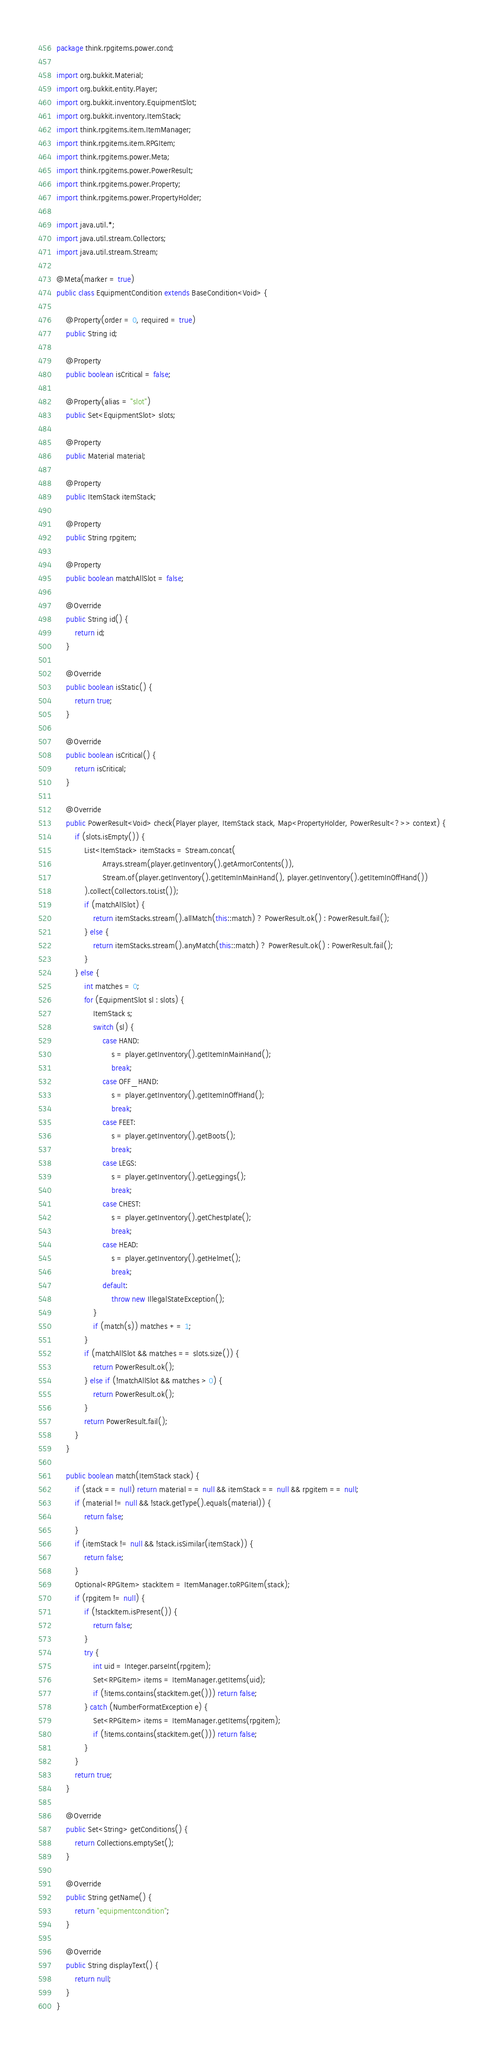Convert code to text. <code><loc_0><loc_0><loc_500><loc_500><_Java_>package think.rpgitems.power.cond;

import org.bukkit.Material;
import org.bukkit.entity.Player;
import org.bukkit.inventory.EquipmentSlot;
import org.bukkit.inventory.ItemStack;
import think.rpgitems.item.ItemManager;
import think.rpgitems.item.RPGItem;
import think.rpgitems.power.Meta;
import think.rpgitems.power.PowerResult;
import think.rpgitems.power.Property;
import think.rpgitems.power.PropertyHolder;

import java.util.*;
import java.util.stream.Collectors;
import java.util.stream.Stream;

@Meta(marker = true)
public class EquipmentCondition extends BaseCondition<Void> {

    @Property(order = 0, required = true)
    public String id;

    @Property
    public boolean isCritical = false;

    @Property(alias = "slot")
    public Set<EquipmentSlot> slots;

    @Property
    public Material material;

    @Property
    public ItemStack itemStack;

    @Property
    public String rpgitem;

    @Property
    public boolean matchAllSlot = false;

    @Override
    public String id() {
        return id;
    }

    @Override
    public boolean isStatic() {
        return true;
    }

    @Override
    public boolean isCritical() {
        return isCritical;
    }

    @Override
    public PowerResult<Void> check(Player player, ItemStack stack, Map<PropertyHolder, PowerResult<?>> context) {
        if (slots.isEmpty()) {
            List<ItemStack> itemStacks = Stream.concat(
                    Arrays.stream(player.getInventory().getArmorContents()),
                    Stream.of(player.getInventory().getItemInMainHand(), player.getInventory().getItemInOffHand())
            ).collect(Collectors.toList());
            if (matchAllSlot) {
                return itemStacks.stream().allMatch(this::match) ? PowerResult.ok() : PowerResult.fail();
            } else {
                return itemStacks.stream().anyMatch(this::match) ? PowerResult.ok() : PowerResult.fail();
            }
        } else {
            int matches = 0;
            for (EquipmentSlot sl : slots) {
                ItemStack s;
                switch (sl) {
                    case HAND:
                        s = player.getInventory().getItemInMainHand();
                        break;
                    case OFF_HAND:
                        s = player.getInventory().getItemInOffHand();
                        break;
                    case FEET:
                        s = player.getInventory().getBoots();
                        break;
                    case LEGS:
                        s = player.getInventory().getLeggings();
                        break;
                    case CHEST:
                        s = player.getInventory().getChestplate();
                        break;
                    case HEAD:
                        s = player.getInventory().getHelmet();
                        break;
                    default:
                        throw new IllegalStateException();
                }
                if (match(s)) matches += 1;
            }
            if (matchAllSlot && matches == slots.size()) {
                return PowerResult.ok();
            } else if (!matchAllSlot && matches > 0) {
                return PowerResult.ok();
            }
            return PowerResult.fail();
        }
    }

    public boolean match(ItemStack stack) {
        if (stack == null) return material == null && itemStack == null && rpgitem == null;
        if (material != null && !stack.getType().equals(material)) {
            return false;
        }
        if (itemStack != null && !stack.isSimilar(itemStack)) {
            return false;
        }
        Optional<RPGItem> stackItem = ItemManager.toRPGItem(stack);
        if (rpgitem != null) {
            if (!stackItem.isPresent()) {
                return false;
            }
            try {
                int uid = Integer.parseInt(rpgitem);
                Set<RPGItem> items = ItemManager.getItems(uid);
                if (!items.contains(stackItem.get())) return false;
            } catch (NumberFormatException e) {
                Set<RPGItem> items = ItemManager.getItems(rpgitem);
                if (!items.contains(stackItem.get())) return false;
            }
        }
        return true;
    }

    @Override
    public Set<String> getConditions() {
        return Collections.emptySet();
    }

    @Override
    public String getName() {
        return "equipmentcondition";
    }

    @Override
    public String displayText() {
        return null;
    }
}
</code> 